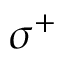<formula> <loc_0><loc_0><loc_500><loc_500>\sigma ^ { + }</formula> 